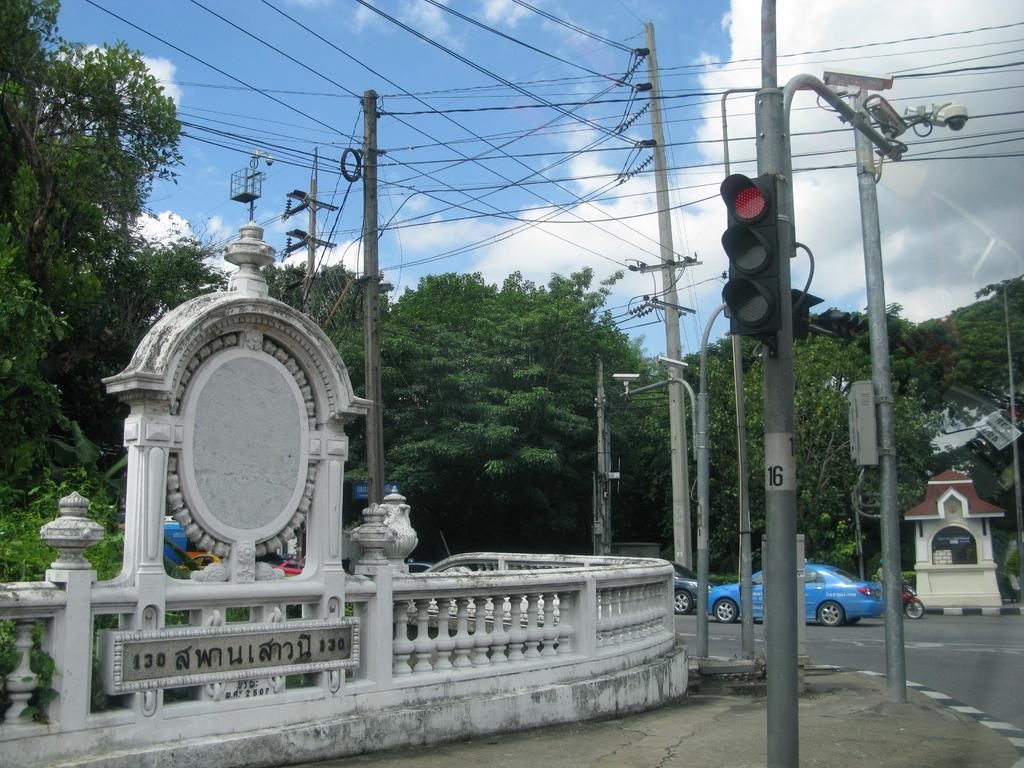Please provide a concise description of this image. This picture is clicked outside the city. On the right we can see a camera and a traffic light attached to the poles and we can see the cables. On the left we can see the railing, planter, poles and trees. In the center there are some vehicles seems to be running on the road. In the background there is a sky with the clouds and we can see the trees and some other objects. 